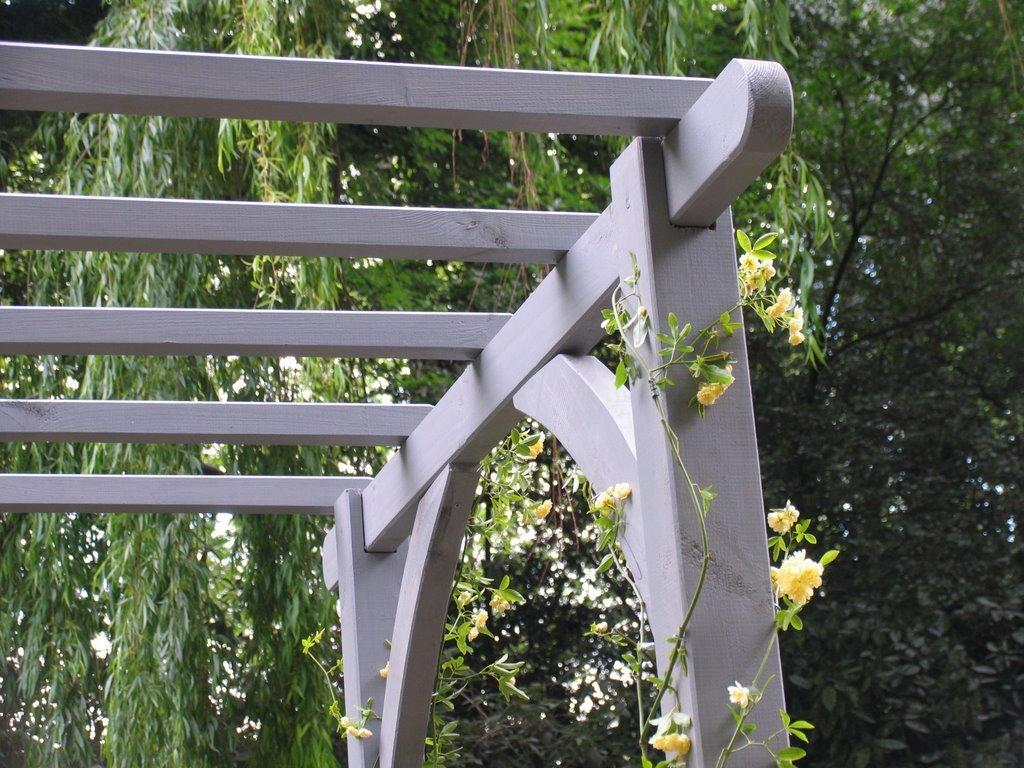What is the main object in the image? There is an ash-colored wooden object in the image. What can be seen in the background of the image? There are many trees in the background of the image. Are there any plants with flowers in the image? Yes, there are yellow-colored flowers on a plant in the image. What type of pickle is being used to invent a new recipe in the image? There is no pickle or mention of a recipe in the image; it features an ash-colored wooden object, trees in the background, and yellow-colored flowers on a plant. 